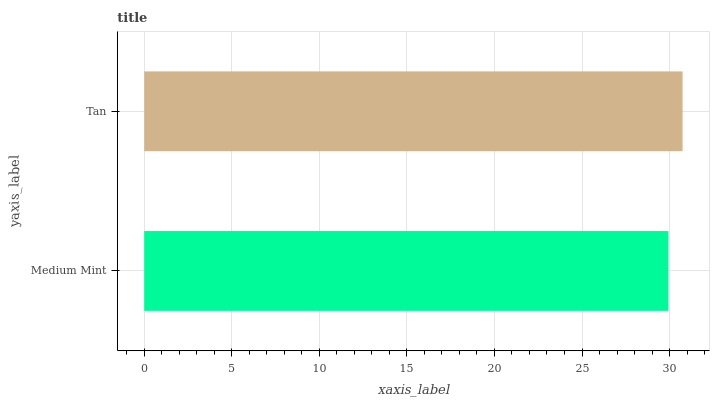Is Medium Mint the minimum?
Answer yes or no. Yes. Is Tan the maximum?
Answer yes or no. Yes. Is Tan the minimum?
Answer yes or no. No. Is Tan greater than Medium Mint?
Answer yes or no. Yes. Is Medium Mint less than Tan?
Answer yes or no. Yes. Is Medium Mint greater than Tan?
Answer yes or no. No. Is Tan less than Medium Mint?
Answer yes or no. No. Is Tan the high median?
Answer yes or no. Yes. Is Medium Mint the low median?
Answer yes or no. Yes. Is Medium Mint the high median?
Answer yes or no. No. Is Tan the low median?
Answer yes or no. No. 